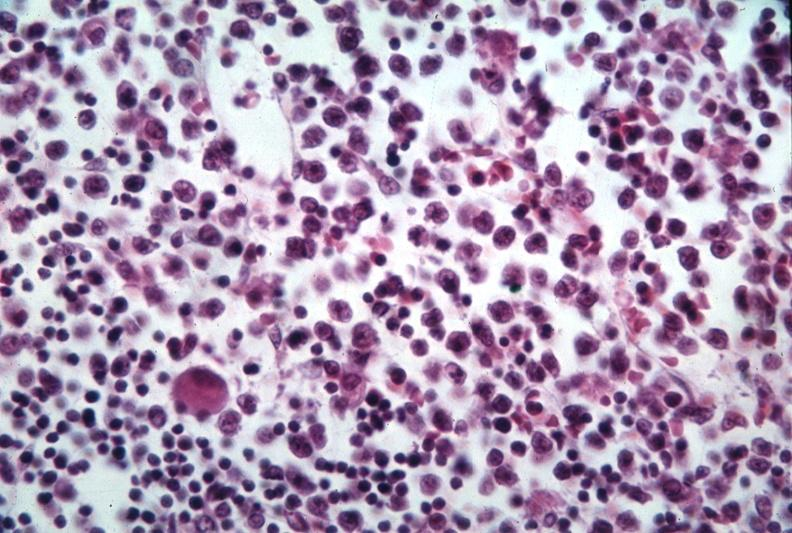what is present?
Answer the question using a single word or phrase. Hematologic 